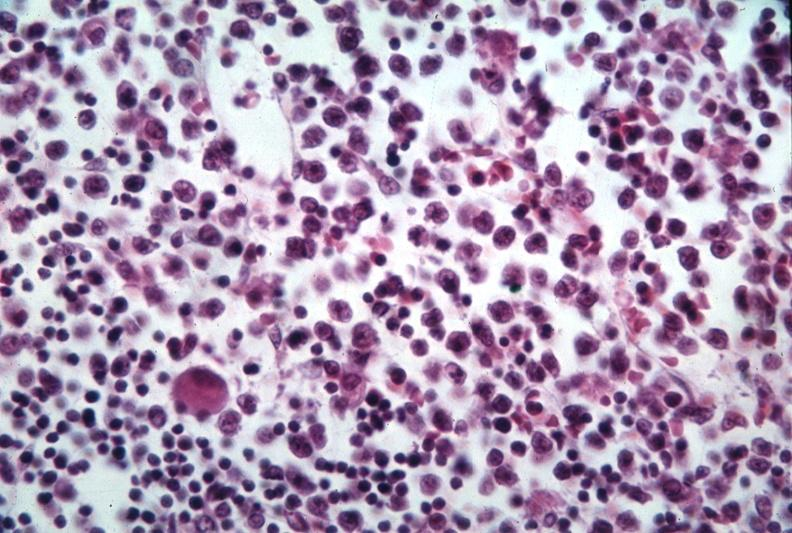what is present?
Answer the question using a single word or phrase. Hematologic 